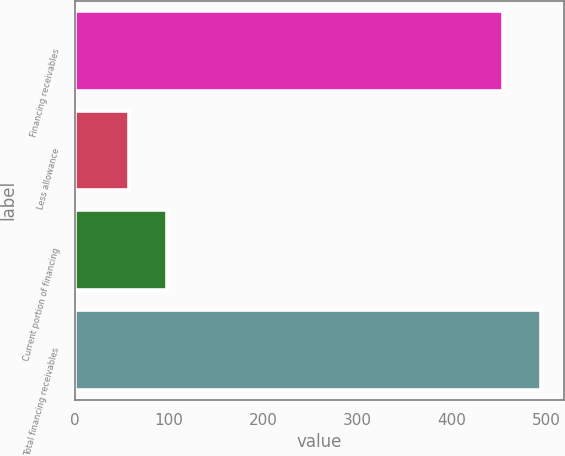Convert chart to OTSL. <chart><loc_0><loc_0><loc_500><loc_500><bar_chart><fcel>Financing receivables<fcel>Less allowance<fcel>Current portion of financing<fcel>Total financing receivables<nl><fcel>454<fcel>58<fcel>98.2<fcel>494.2<nl></chart> 